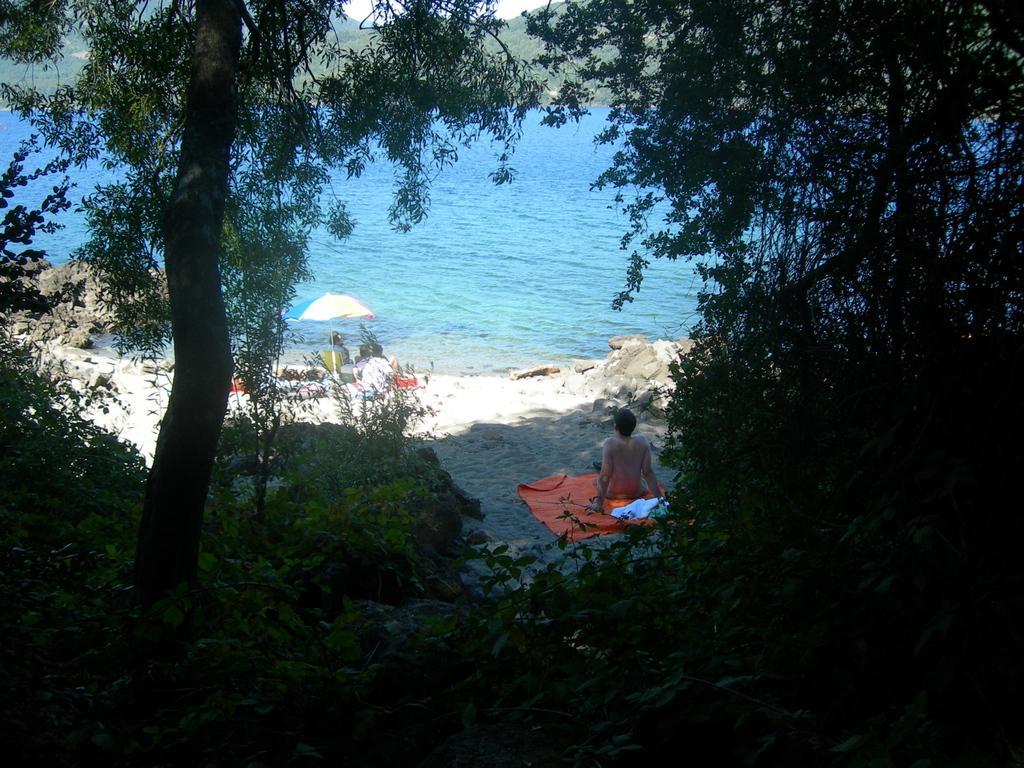How would you summarize this image in a sentence or two? In this image there is a beach in front of that there is a tent where people are sitting under it and also there is another man sitting on the cloth, behind them there are so many trees. 